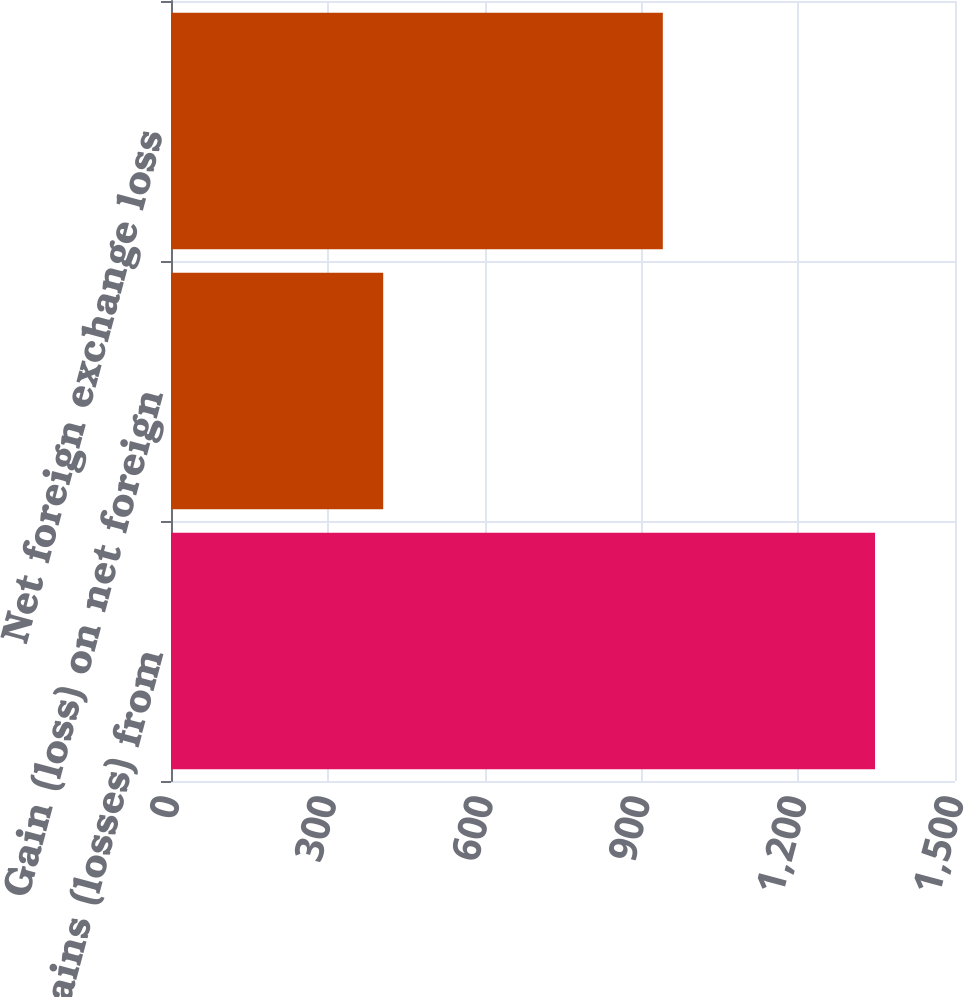<chart> <loc_0><loc_0><loc_500><loc_500><bar_chart><fcel>Change in gains (losses) from<fcel>Gain (loss) on net foreign<fcel>Net foreign exchange loss<nl><fcel>1347<fcel>406<fcel>941<nl></chart> 